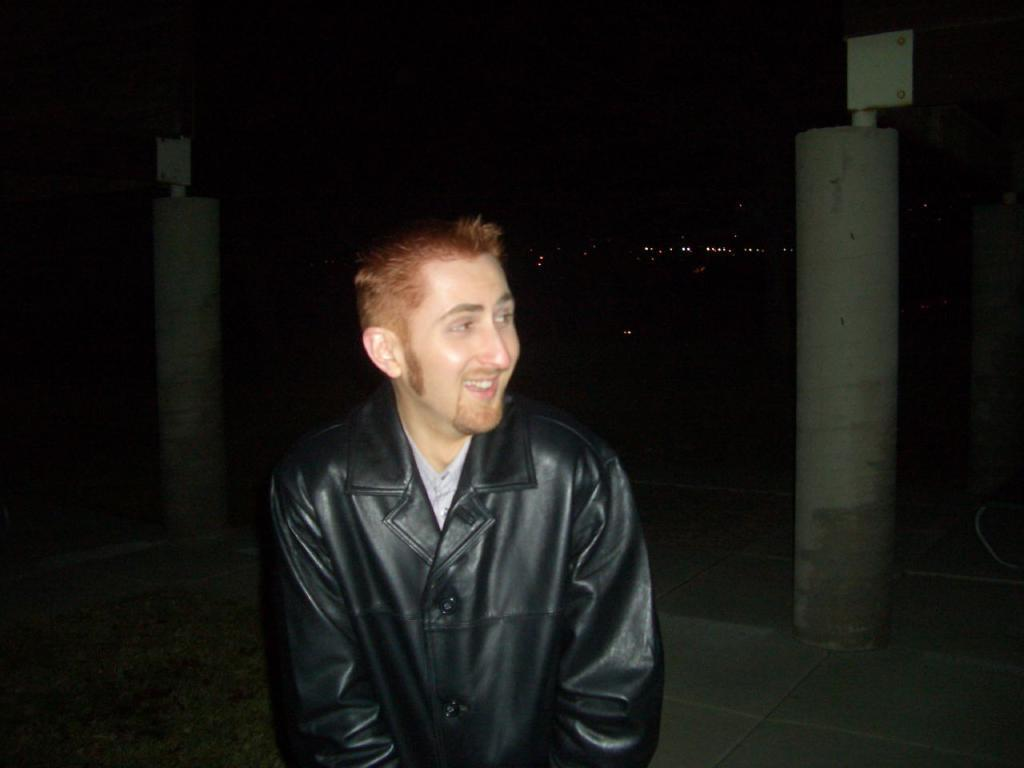Who is present in the image? There is a man in the image. What is the man's facial expression? The man is smiling. What can be seen in the background of the image? There are pillars in the background of the image. How would you describe the lighting in the image? The background of the image is dark. What type of mitten is the man wearing in the image? There is no mitten present in the image; the man is not wearing any gloves or mittens. How many clouds can be seen in the image? There are no clouds visible in the image, as the background is dark and does not show any sky or clouds. 